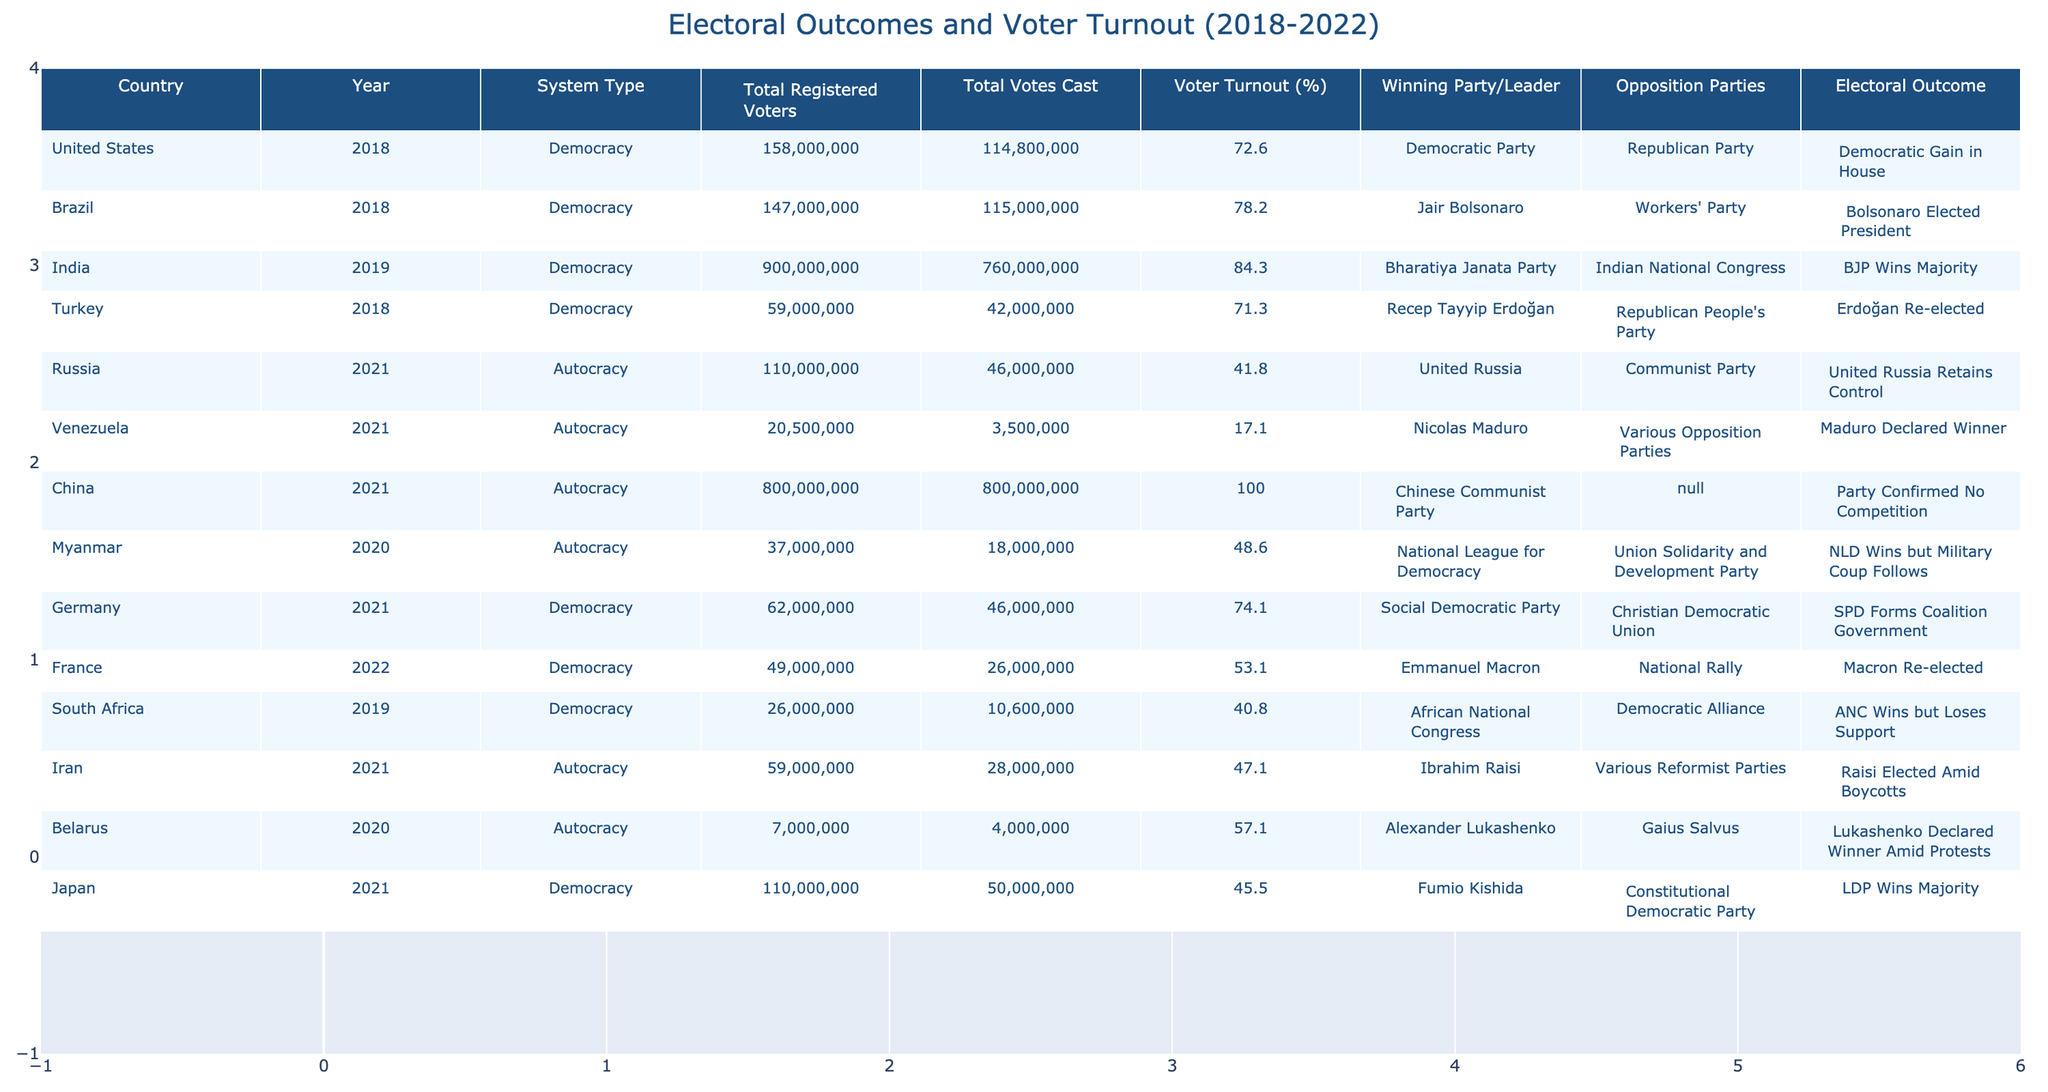What is the voter turnout percentage for the United States in 2018? Referring to the table, the voter turnout percentage for the United States in 2018 is listed directly next to the country name and year. It shows a value of 72.6%.
Answer: 72.6% Which country had the highest voter turnout between 2018 and 2022? By scanning the voter turnout percentages in the table, India in 2019 shows the highest value at 84.3%.
Answer: India What is the total number of registered voters in Brazil in 2018? Looking at the table, Brazil has a total of 147,000,000 registered voters as stated in the corresponding cell for that year.
Answer: 147,000,000 How many total votes were cast in the 2021 election in China? The table indicates that in China, there were 800,000,000 total votes cast in the 2021 election.
Answer: 800,000,000 What was the electoral outcome in Venezuela in 2021? The table states that Nicolas Maduro was declared the winner in the 2021 election in Venezuela.
Answer: Maduro Declared Winner Is the statement "Total votes cast in South Africa in 2019 exceeded 10 million" true? Checking the table shows that the total votes cast in South Africa in 2019 was 10,600,000, which is indeed greater than 10 million.
Answer: True Calculate the average voter turnout percentage for democracies listed in the table. First, identify the voter turnout percentages for the democracies: 72.6, 78.2, 84.3, 71.3, 74.1, 53.1, 40.8, and 45.5. Summing these gives 72.6 + 78.2 + 84.3 + 71.3 + 74.1 + 53.1 + 40.8 + 45.5 = 520.9. There are 8 values, so the average is 520.9 / 8 = 65.1.
Answer: 65.1 Which party won the most elections in the table? By reviewing the electoral outcomes, we see the Democratic Party won a seat in the US House in 2018, Jair Bolsonaro won in Brazil, the BJP in India, Erdoğan in Turkey, SPD in Germany, and Macron in France. The total number of winning parties (including autocracies) yields a tally, revealing that the Chinese Communist Party was confirmed without competition. Counting democratic winners shows six unique outcomes. Therefore, the winning is more diverse, but no single party dominated consistently.
Answer: No specific party dominated In which system type did the lowest voter turnout occur? Examining the voter turnout percentages under both system types reveals that Venezuela, an autocracy, had the lowest turnout at 17.1%.
Answer: Autocracy (Venezuela 17.1%) What was the difference in voter turnout between India in 2019 and Russia in 2021? India had a voter turnout of 84.3% and Russia had 41.8%. The difference is calculated as 84.3 - 41.8 = 42.5%.
Answer: 42.5% 